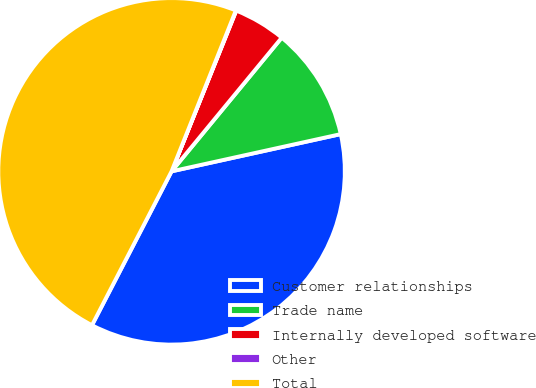Convert chart to OTSL. <chart><loc_0><loc_0><loc_500><loc_500><pie_chart><fcel>Customer relationships<fcel>Trade name<fcel>Internally developed software<fcel>Other<fcel>Total<nl><fcel>36.04%<fcel>10.58%<fcel>4.88%<fcel>0.04%<fcel>48.45%<nl></chart> 